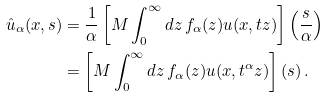<formula> <loc_0><loc_0><loc_500><loc_500>\hat { u } _ { \alpha } ( x , s ) & = \frac { 1 } { \alpha } \left [ M \int _ { 0 } ^ { \infty } d z \, f _ { \alpha } ( z ) u ( x , t z ) \right ] \left ( \frac { s } { \alpha } \right ) \\ & = \left [ M \int _ { 0 } ^ { \infty } d z \, f _ { \alpha } ( z ) u ( x , t ^ { \alpha } z ) \right ] ( s ) \, .</formula> 